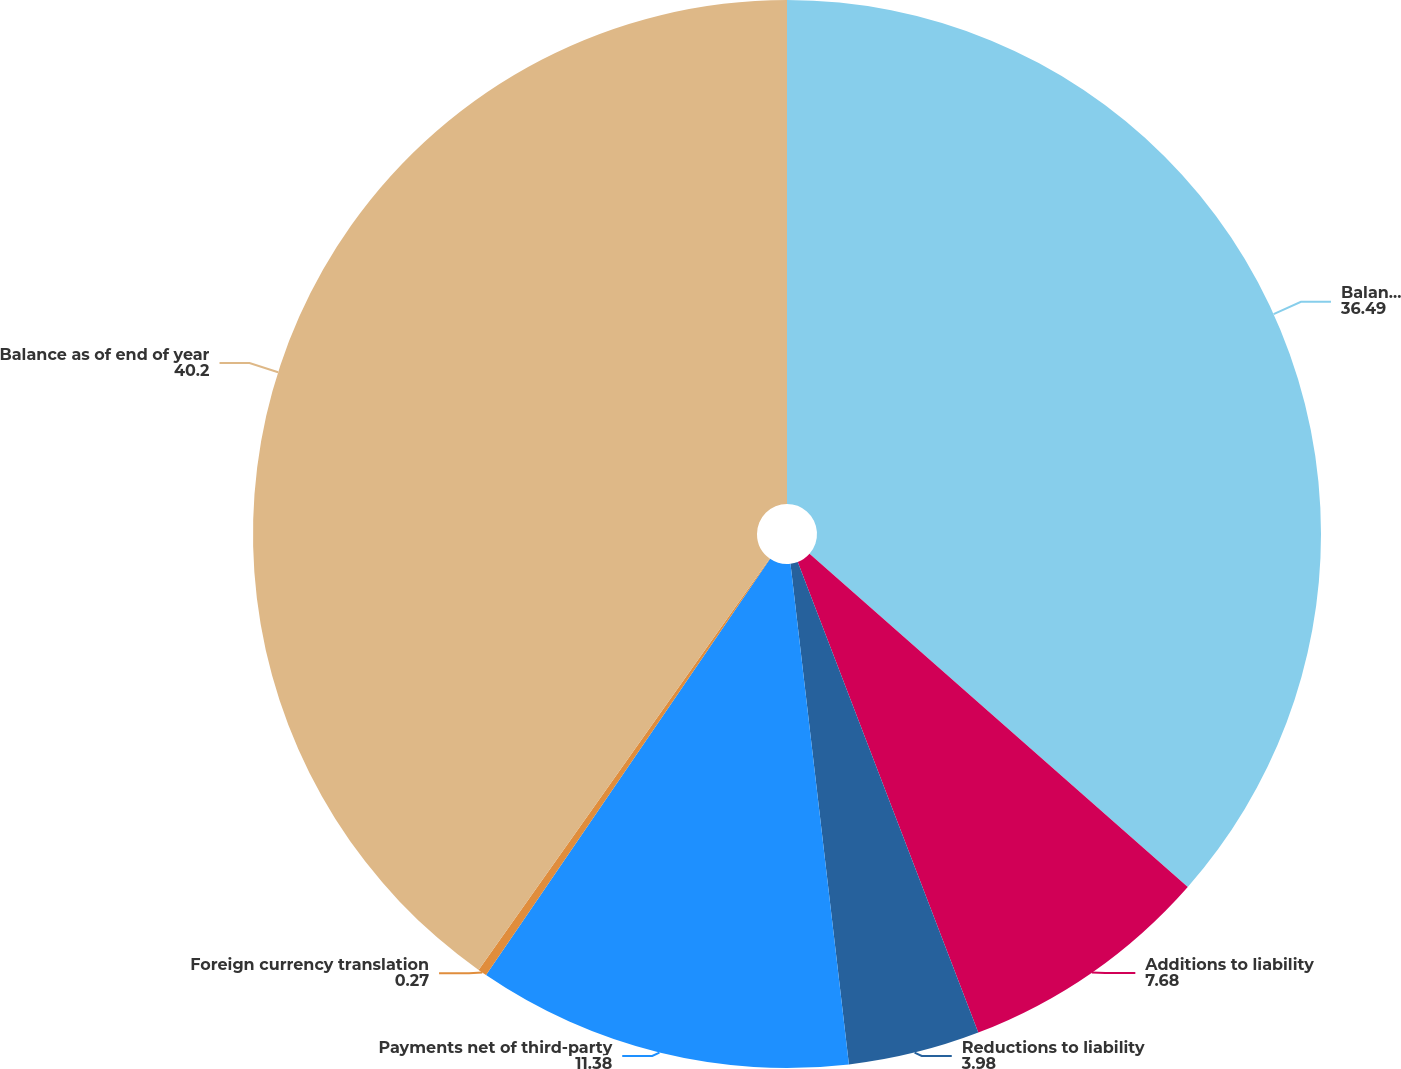Convert chart to OTSL. <chart><loc_0><loc_0><loc_500><loc_500><pie_chart><fcel>Balance as of beginning of<fcel>Additions to liability<fcel>Reductions to liability<fcel>Payments net of third-party<fcel>Foreign currency translation<fcel>Balance as of end of year<nl><fcel>36.49%<fcel>7.68%<fcel>3.98%<fcel>11.38%<fcel>0.27%<fcel>40.2%<nl></chart> 